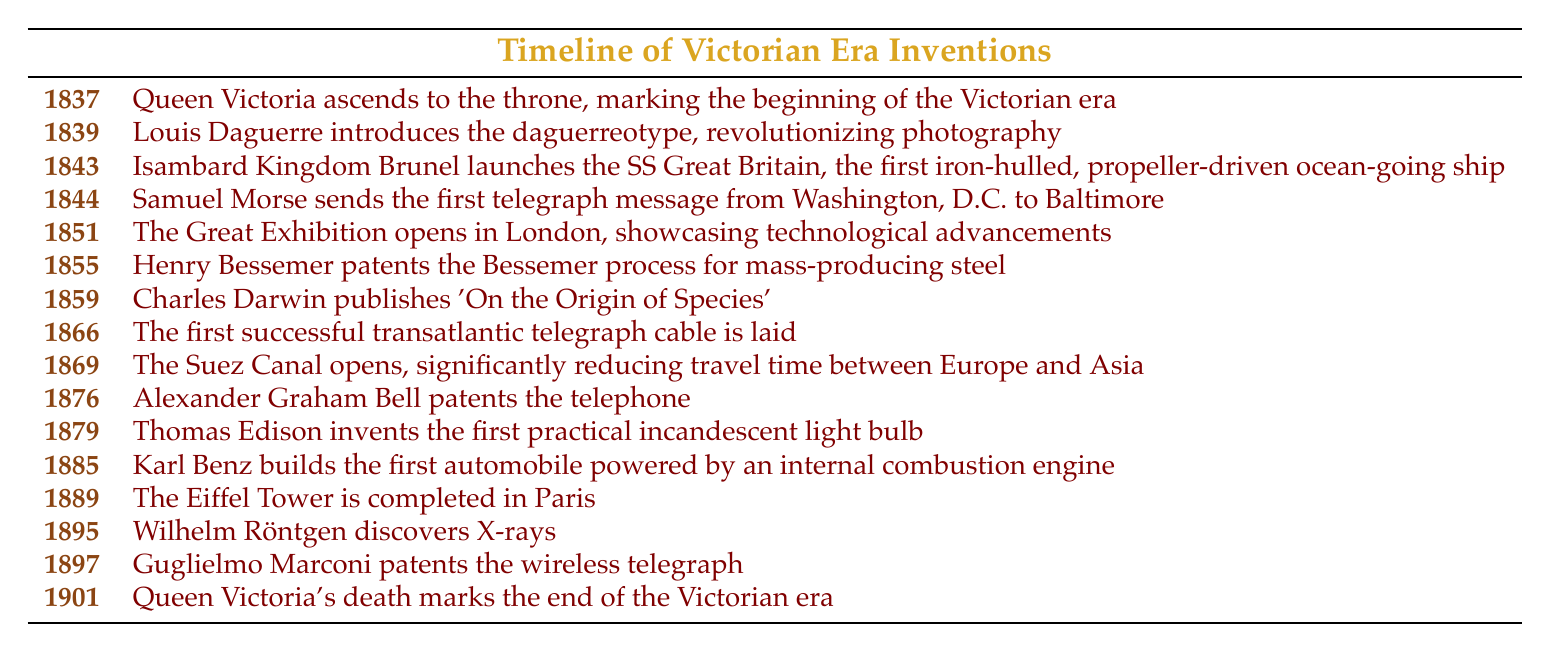What significant invention was introduced in 1839? The table shows that in 1839, Louis Daguerre introduced the daguerreotype, which revolutionized photography.
Answer: The daguerreotype Which event happened first, the launch of the SS Great Britain or the sending of the first telegraph message? From the table, the SS Great Britain was launched in 1843 and the first telegraph message was sent in 1844. Since 1843 comes before 1844, the launch of the SS Great Britain occurred first.
Answer: The launch of the SS Great Britain How many years elapsed between the opening of the Suez Canal and Queen Victoria's death? The Suez Canal opened in 1869 and Queen Victoria died in 1901. To find the number of years between these two events, subtract 1869 from 1901, which results in 32 years.
Answer: 32 years Did Henry Bessemer patent the Bessemer process before or after the Great Exhibition? The Great Exhibition opened in 1851 and Henry Bessemer patented the Bessemer process in 1855. Since 1855 is after 1851, he patented it after the Great Exhibition.
Answer: After How many inventions or events related to communication are listed in the table? The table includes three communication-related events: the telegraph in 1844, the telephone in 1876, and the wireless telegraph in 1897. Thus, by counting these occurrences, we can see there are three events.
Answer: Three events Which year had the invention of both the telephone and the incandescent light bulb, and what is their significance? The telephone was patented in 1876 and the light bulb was invented in 1879; thus, they did not occur in the same year. They are significant as they represent major advancements in communication and lighting technologies, respectively. The years are different.
Answer: Different years What other major event happened in 1895 aside from the discovery of X-rays? The table shows that 1895 marks Wilhelm Röntgen's discovery of X-rays, and no other significant event is recorded for that year, making it the only major event listed.
Answer: None What was the impact of the Suez Canal opening on travel time between Europe and Asia? The Suez Canal opening in 1869 significantly reduced travel time between Europe and Asia by providing a direct sea route, showing how it transformed maritime trade and travel.
Answer: Reduced travel time 